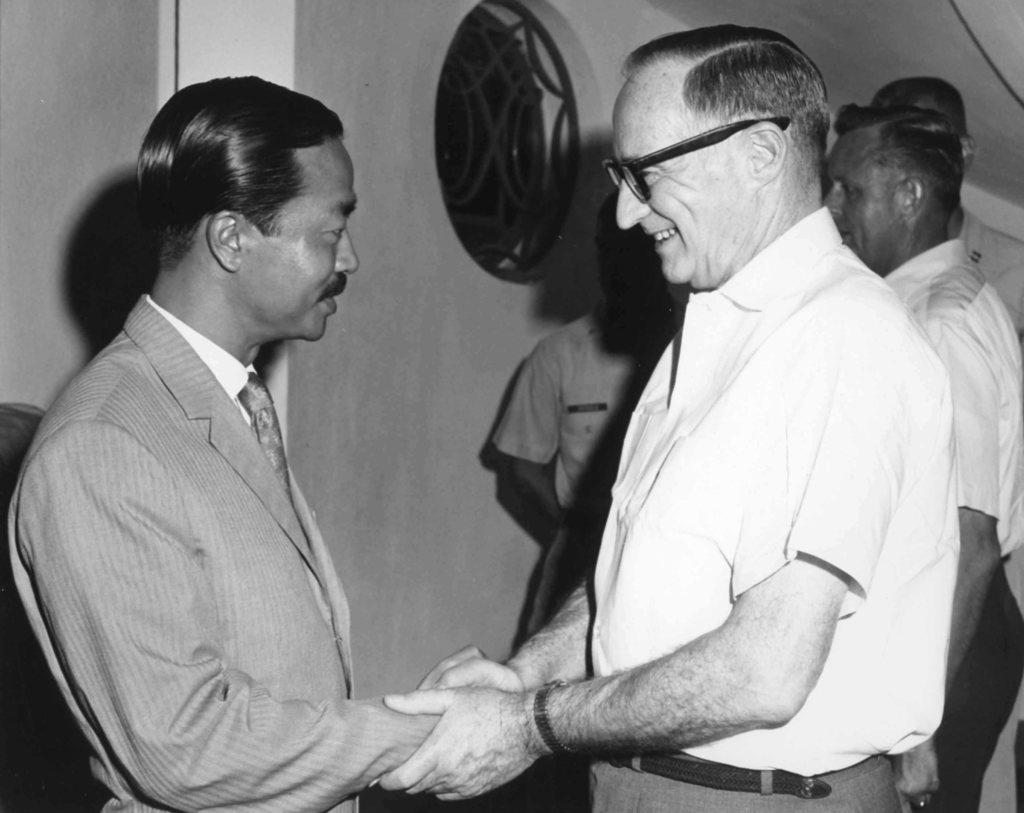What is the color scheme of the image? The image is black and white. What can be seen in the foreground of the image? There is a group of people standing in the image. What is visible in the background of the image? There is a wall visible behind the people, and there is an object behind the people as well. What type of air can be seen surrounding the people in the image? There is no air visible in the image, as it is a black and white photograph. What emotion might the people be feeling based on their body language in the image? We cannot determine the emotions of the people based on their body language in the image, as it is a black and white photograph. 